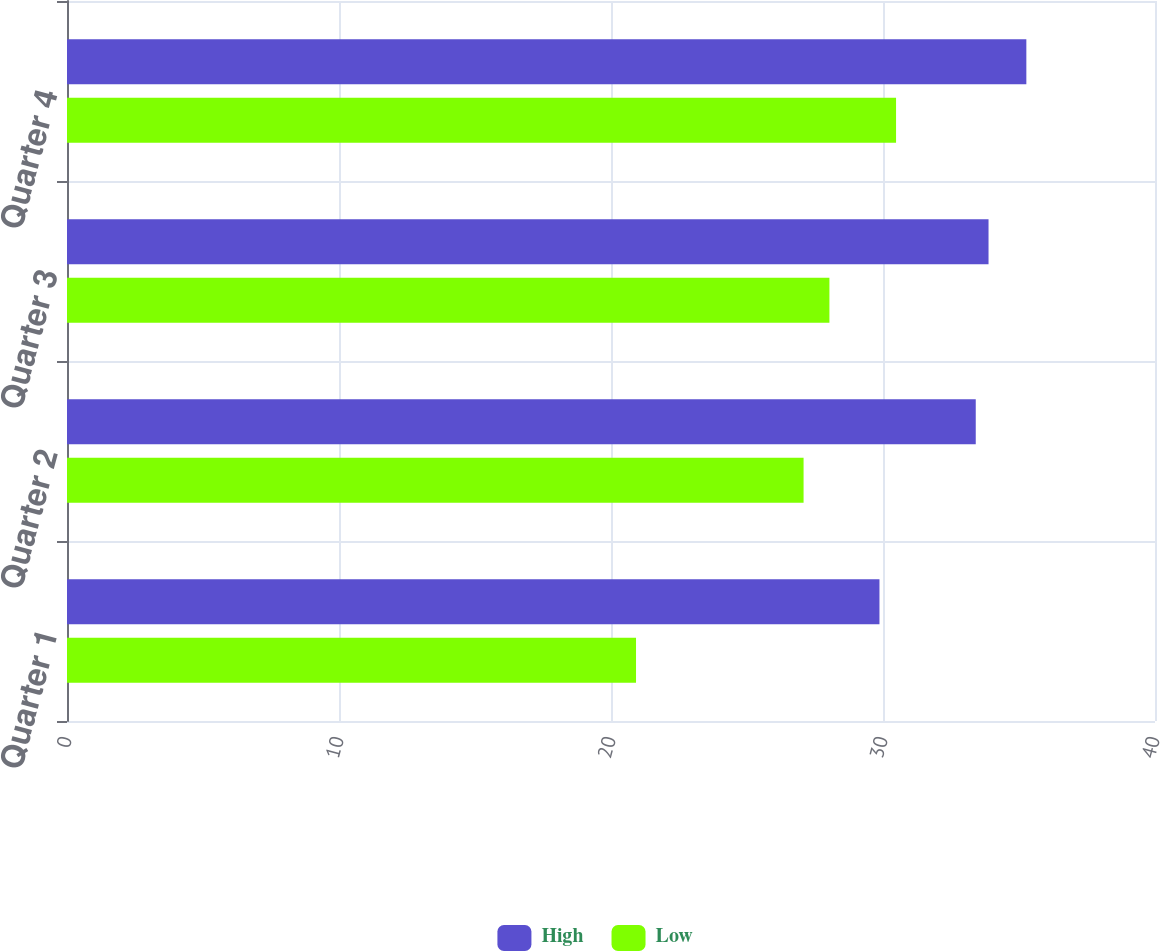<chart> <loc_0><loc_0><loc_500><loc_500><stacked_bar_chart><ecel><fcel>Quarter 1<fcel>Quarter 2<fcel>Quarter 3<fcel>Quarter 4<nl><fcel>High<fcel>29.87<fcel>33.41<fcel>33.88<fcel>35.27<nl><fcel>Low<fcel>20.92<fcel>27.08<fcel>28.03<fcel>30.48<nl></chart> 